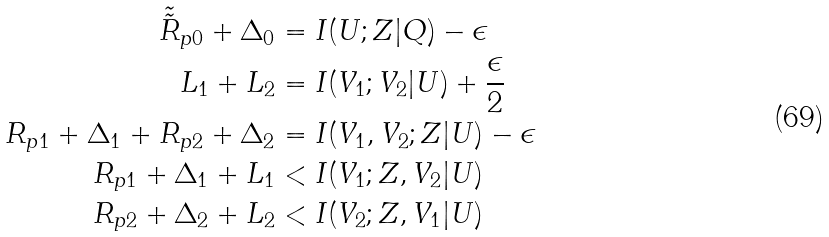<formula> <loc_0><loc_0><loc_500><loc_500>\tilde { \tilde { R } } _ { p 0 } + \Delta _ { 0 } & = I ( U ; Z | Q ) - \epsilon \\ L _ { 1 } + L _ { 2 } & = I ( V _ { 1 } ; V _ { 2 } | U ) + \frac { \epsilon } { 2 } \\ R _ { p 1 } + \Delta _ { 1 } + R _ { p 2 } + \Delta _ { 2 } & = I ( V _ { 1 } , V _ { 2 } ; Z | U ) - \epsilon \\ R _ { p 1 } + \Delta _ { 1 } + L _ { 1 } & < I ( V _ { 1 } ; Z , V _ { 2 } | U ) \\ R _ { p 2 } + \Delta _ { 2 } + L _ { 2 } & < I ( V _ { 2 } ; Z , V _ { 1 } | U )</formula> 